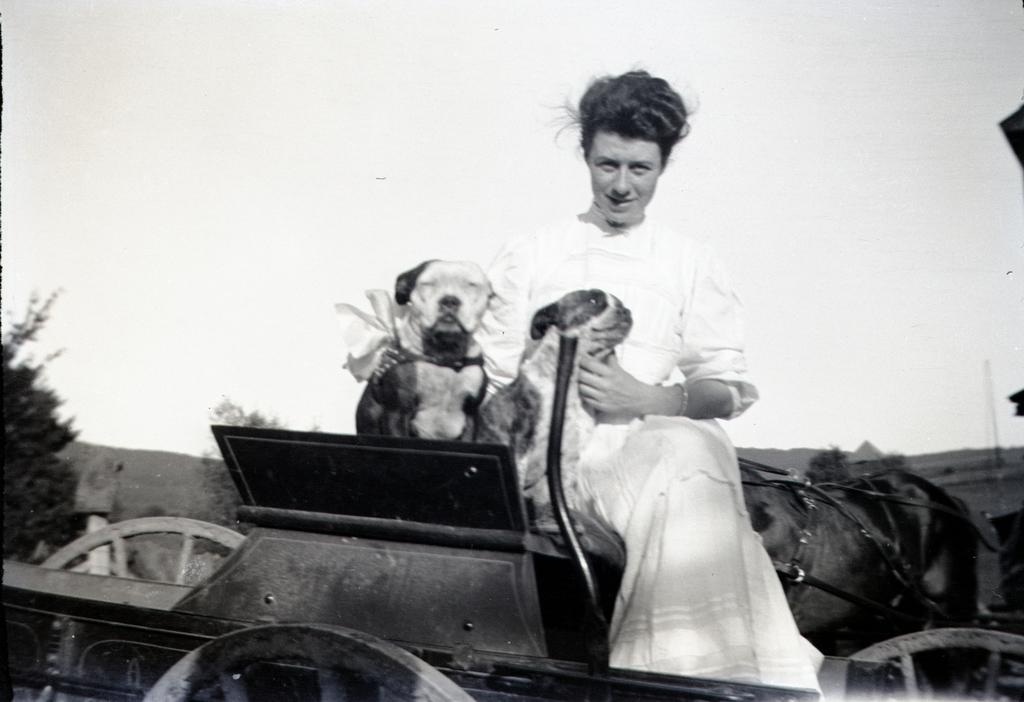Who is present in the image? There is a woman in the image. What is the woman doing in the image? The woman is sitting. Is there any animal present in the image? Yes, there is a dog beside the woman. What else can be seen in the image? There is a chart in the image. What type of natural scenery is visible in the image? There are trees visible in the image. Where is the library located in the image? There is no library present in the image. What type of bee can be seen buzzing around the woman in the image? There are no bees present in the image. 